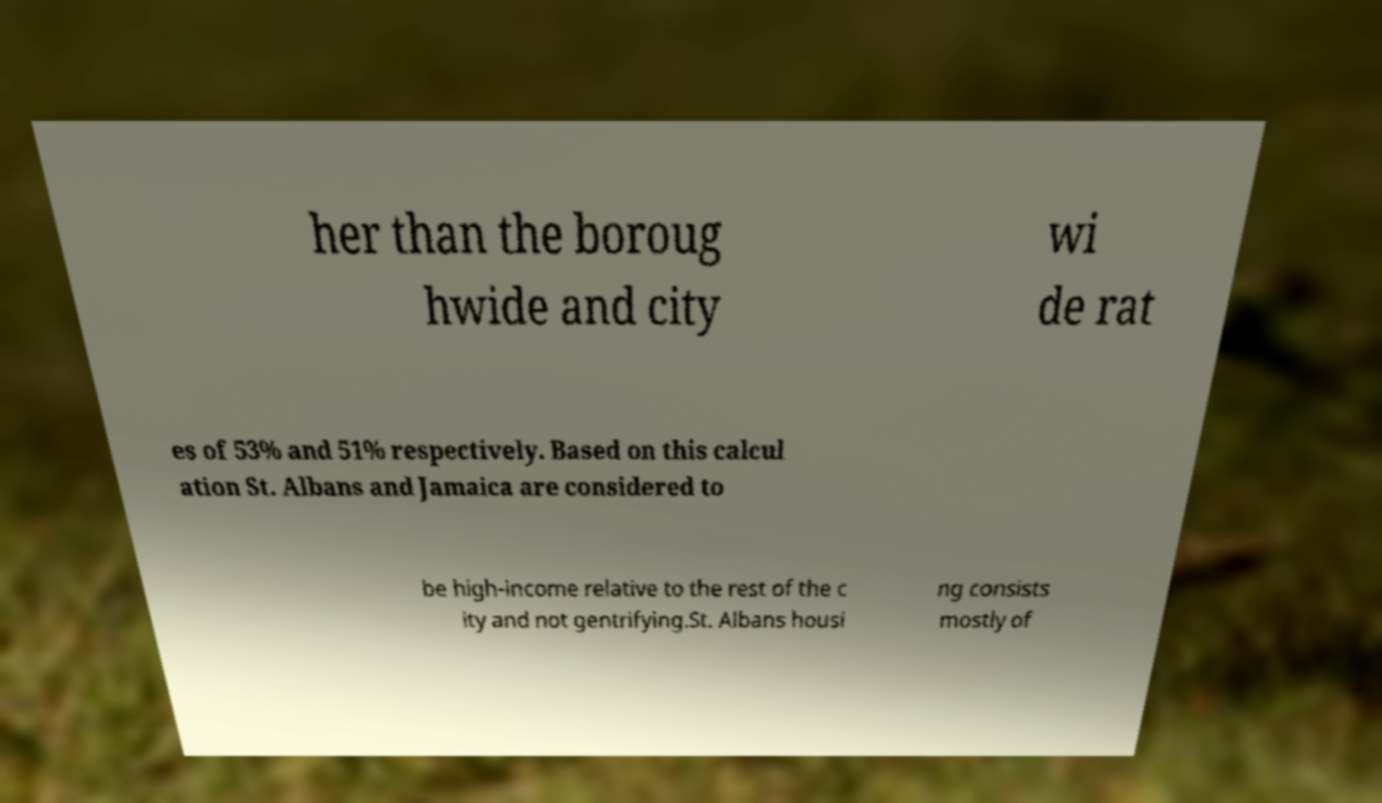Can you accurately transcribe the text from the provided image for me? her than the boroug hwide and city wi de rat es of 53% and 51% respectively. Based on this calcul ation St. Albans and Jamaica are considered to be high-income relative to the rest of the c ity and not gentrifying.St. Albans housi ng consists mostly of 